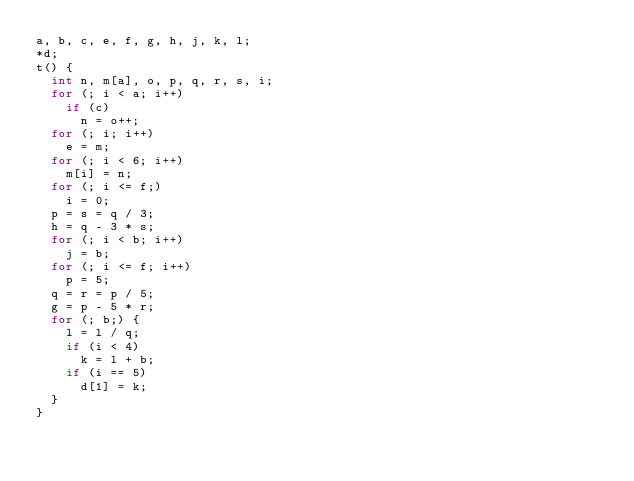Convert code to text. <code><loc_0><loc_0><loc_500><loc_500><_C_>a, b, c, e, f, g, h, j, k, l;
*d;
t() {
  int n, m[a], o, p, q, r, s, i;
  for (; i < a; i++)
    if (c)
      n = o++;
  for (; i; i++)
    e = m;
  for (; i < 6; i++)
    m[i] = n;
  for (; i <= f;)
    i = 0;
  p = s = q / 3;
  h = q - 3 * s;
  for (; i < b; i++)
    j = b;
  for (; i <= f; i++)
    p = 5;
  q = r = p / 5;
  g = p - 5 * r;
  for (; b;) {
    l = l / q;
    if (i < 4)
      k = l + b;
    if (i == 5)
      d[1] = k;
  }
}
</code> 